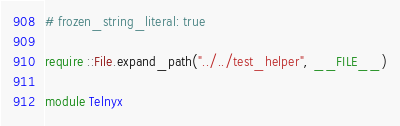Convert code to text. <code><loc_0><loc_0><loc_500><loc_500><_Ruby_># frozen_string_literal: true

require ::File.expand_path("../../test_helper", __FILE__)

module Telnyx</code> 